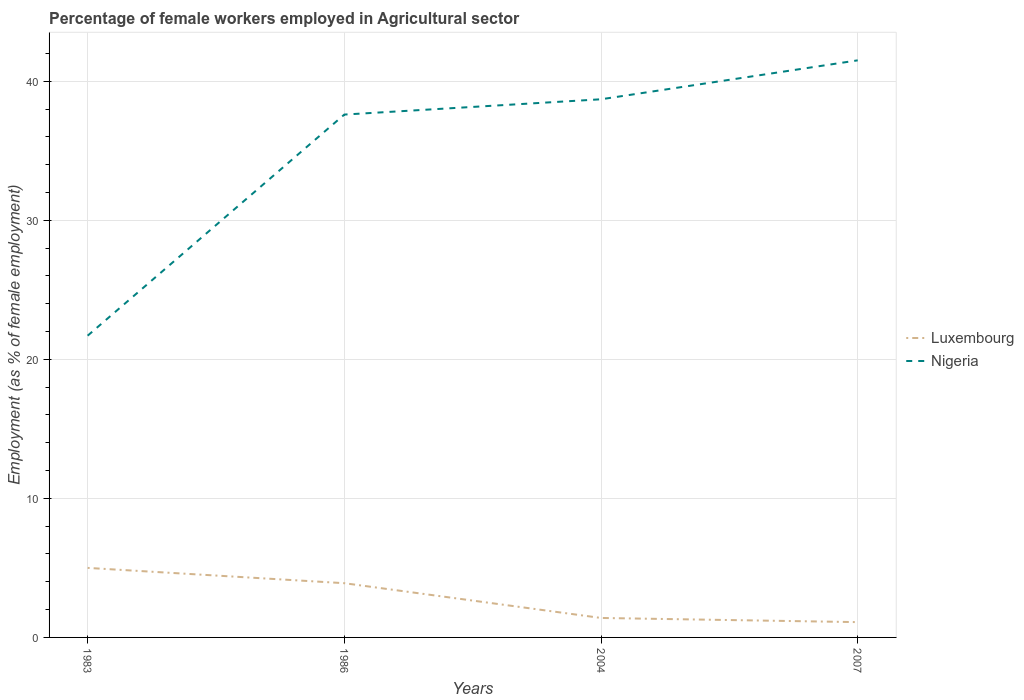How many different coloured lines are there?
Provide a succinct answer. 2. Does the line corresponding to Luxembourg intersect with the line corresponding to Nigeria?
Offer a very short reply. No. Across all years, what is the maximum percentage of females employed in Agricultural sector in Nigeria?
Offer a very short reply. 21.7. What is the total percentage of females employed in Agricultural sector in Nigeria in the graph?
Offer a terse response. -3.9. What is the difference between the highest and the second highest percentage of females employed in Agricultural sector in Luxembourg?
Give a very brief answer. 3.9. What is the difference between the highest and the lowest percentage of females employed in Agricultural sector in Nigeria?
Offer a very short reply. 3. Is the percentage of females employed in Agricultural sector in Nigeria strictly greater than the percentage of females employed in Agricultural sector in Luxembourg over the years?
Your answer should be compact. No. What is the difference between two consecutive major ticks on the Y-axis?
Make the answer very short. 10. How many legend labels are there?
Give a very brief answer. 2. How are the legend labels stacked?
Make the answer very short. Vertical. What is the title of the graph?
Offer a very short reply. Percentage of female workers employed in Agricultural sector. Does "Hungary" appear as one of the legend labels in the graph?
Your answer should be compact. No. What is the label or title of the X-axis?
Your answer should be very brief. Years. What is the label or title of the Y-axis?
Offer a terse response. Employment (as % of female employment). What is the Employment (as % of female employment) in Nigeria in 1983?
Ensure brevity in your answer.  21.7. What is the Employment (as % of female employment) of Luxembourg in 1986?
Keep it short and to the point. 3.9. What is the Employment (as % of female employment) of Nigeria in 1986?
Give a very brief answer. 37.6. What is the Employment (as % of female employment) of Luxembourg in 2004?
Your answer should be compact. 1.4. What is the Employment (as % of female employment) in Nigeria in 2004?
Make the answer very short. 38.7. What is the Employment (as % of female employment) in Luxembourg in 2007?
Provide a succinct answer. 1.1. What is the Employment (as % of female employment) of Nigeria in 2007?
Your answer should be very brief. 41.5. Across all years, what is the maximum Employment (as % of female employment) in Luxembourg?
Your answer should be very brief. 5. Across all years, what is the maximum Employment (as % of female employment) of Nigeria?
Your answer should be compact. 41.5. Across all years, what is the minimum Employment (as % of female employment) of Luxembourg?
Provide a short and direct response. 1.1. Across all years, what is the minimum Employment (as % of female employment) of Nigeria?
Keep it short and to the point. 21.7. What is the total Employment (as % of female employment) of Luxembourg in the graph?
Your answer should be very brief. 11.4. What is the total Employment (as % of female employment) of Nigeria in the graph?
Offer a very short reply. 139.5. What is the difference between the Employment (as % of female employment) of Luxembourg in 1983 and that in 1986?
Your answer should be very brief. 1.1. What is the difference between the Employment (as % of female employment) of Nigeria in 1983 and that in 1986?
Keep it short and to the point. -15.9. What is the difference between the Employment (as % of female employment) in Luxembourg in 1983 and that in 2004?
Provide a succinct answer. 3.6. What is the difference between the Employment (as % of female employment) of Nigeria in 1983 and that in 2004?
Make the answer very short. -17. What is the difference between the Employment (as % of female employment) in Luxembourg in 1983 and that in 2007?
Offer a very short reply. 3.9. What is the difference between the Employment (as % of female employment) of Nigeria in 1983 and that in 2007?
Your answer should be very brief. -19.8. What is the difference between the Employment (as % of female employment) in Luxembourg in 1983 and the Employment (as % of female employment) in Nigeria in 1986?
Make the answer very short. -32.6. What is the difference between the Employment (as % of female employment) in Luxembourg in 1983 and the Employment (as % of female employment) in Nigeria in 2004?
Keep it short and to the point. -33.7. What is the difference between the Employment (as % of female employment) in Luxembourg in 1983 and the Employment (as % of female employment) in Nigeria in 2007?
Provide a short and direct response. -36.5. What is the difference between the Employment (as % of female employment) of Luxembourg in 1986 and the Employment (as % of female employment) of Nigeria in 2004?
Provide a succinct answer. -34.8. What is the difference between the Employment (as % of female employment) in Luxembourg in 1986 and the Employment (as % of female employment) in Nigeria in 2007?
Make the answer very short. -37.6. What is the difference between the Employment (as % of female employment) in Luxembourg in 2004 and the Employment (as % of female employment) in Nigeria in 2007?
Provide a succinct answer. -40.1. What is the average Employment (as % of female employment) of Luxembourg per year?
Provide a short and direct response. 2.85. What is the average Employment (as % of female employment) in Nigeria per year?
Your response must be concise. 34.88. In the year 1983, what is the difference between the Employment (as % of female employment) of Luxembourg and Employment (as % of female employment) of Nigeria?
Offer a very short reply. -16.7. In the year 1986, what is the difference between the Employment (as % of female employment) in Luxembourg and Employment (as % of female employment) in Nigeria?
Give a very brief answer. -33.7. In the year 2004, what is the difference between the Employment (as % of female employment) of Luxembourg and Employment (as % of female employment) of Nigeria?
Offer a terse response. -37.3. In the year 2007, what is the difference between the Employment (as % of female employment) of Luxembourg and Employment (as % of female employment) of Nigeria?
Your answer should be very brief. -40.4. What is the ratio of the Employment (as % of female employment) of Luxembourg in 1983 to that in 1986?
Your answer should be compact. 1.28. What is the ratio of the Employment (as % of female employment) of Nigeria in 1983 to that in 1986?
Your answer should be very brief. 0.58. What is the ratio of the Employment (as % of female employment) in Luxembourg in 1983 to that in 2004?
Keep it short and to the point. 3.57. What is the ratio of the Employment (as % of female employment) in Nigeria in 1983 to that in 2004?
Offer a very short reply. 0.56. What is the ratio of the Employment (as % of female employment) of Luxembourg in 1983 to that in 2007?
Your response must be concise. 4.55. What is the ratio of the Employment (as % of female employment) of Nigeria in 1983 to that in 2007?
Ensure brevity in your answer.  0.52. What is the ratio of the Employment (as % of female employment) in Luxembourg in 1986 to that in 2004?
Offer a very short reply. 2.79. What is the ratio of the Employment (as % of female employment) of Nigeria in 1986 to that in 2004?
Make the answer very short. 0.97. What is the ratio of the Employment (as % of female employment) of Luxembourg in 1986 to that in 2007?
Give a very brief answer. 3.55. What is the ratio of the Employment (as % of female employment) in Nigeria in 1986 to that in 2007?
Offer a very short reply. 0.91. What is the ratio of the Employment (as % of female employment) in Luxembourg in 2004 to that in 2007?
Your response must be concise. 1.27. What is the ratio of the Employment (as % of female employment) in Nigeria in 2004 to that in 2007?
Keep it short and to the point. 0.93. What is the difference between the highest and the second highest Employment (as % of female employment) of Luxembourg?
Give a very brief answer. 1.1. What is the difference between the highest and the second highest Employment (as % of female employment) of Nigeria?
Offer a very short reply. 2.8. What is the difference between the highest and the lowest Employment (as % of female employment) in Luxembourg?
Offer a very short reply. 3.9. What is the difference between the highest and the lowest Employment (as % of female employment) in Nigeria?
Your answer should be compact. 19.8. 